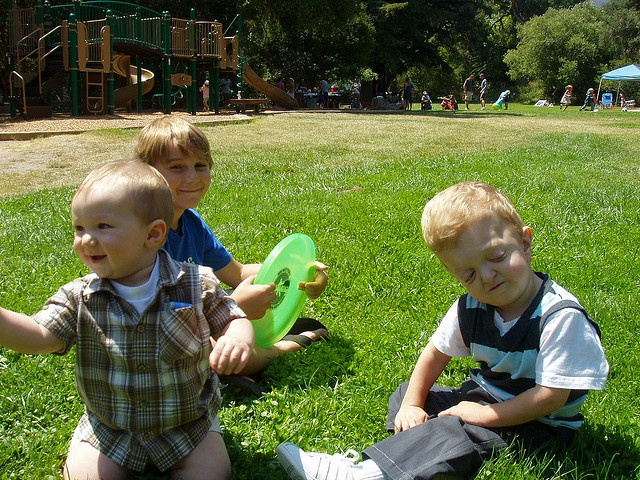Describe the objects in this image and their specific colors. I can see people in black, gray, olive, and ivory tones, people in black, ivory, gray, and olive tones, people in black, olive, maroon, and navy tones, frisbee in black, green, and lightgreen tones, and people in black, gray, darkgreen, and maroon tones in this image. 